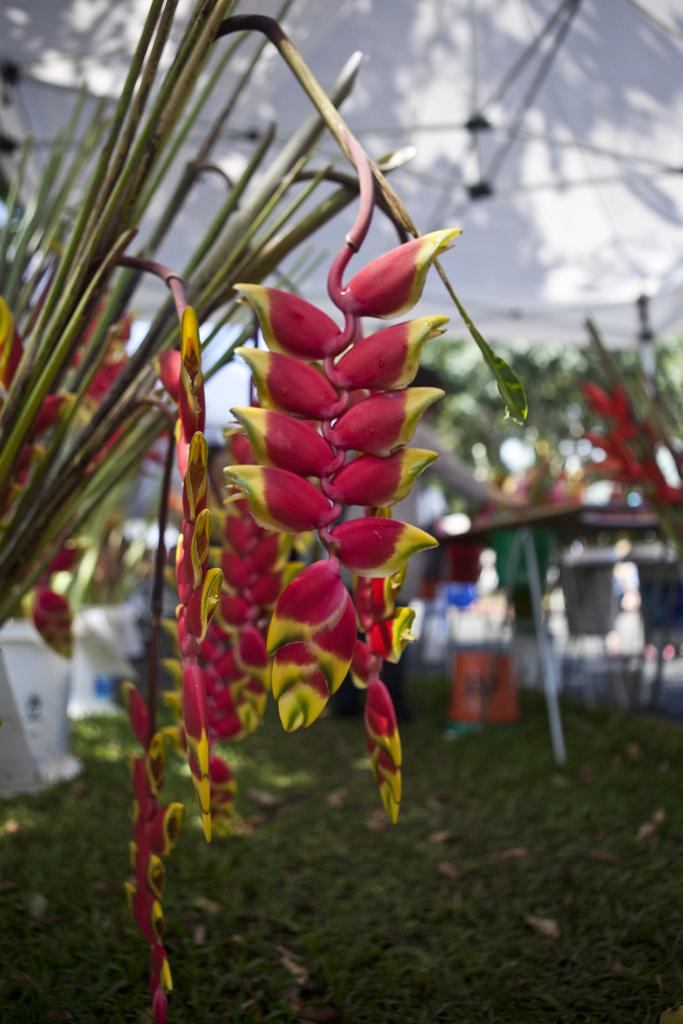What is located in the foreground of the image? There are flowers in the foreground of the image. What type of vegetation is at the bottom of the image? There is grass at the bottom of the image. How would you describe the background of the image? The background of the image is blurred. Can you see any holes in the earth in the image? There is no reference to the earth or any holes in the image; it features flowers and grass. 